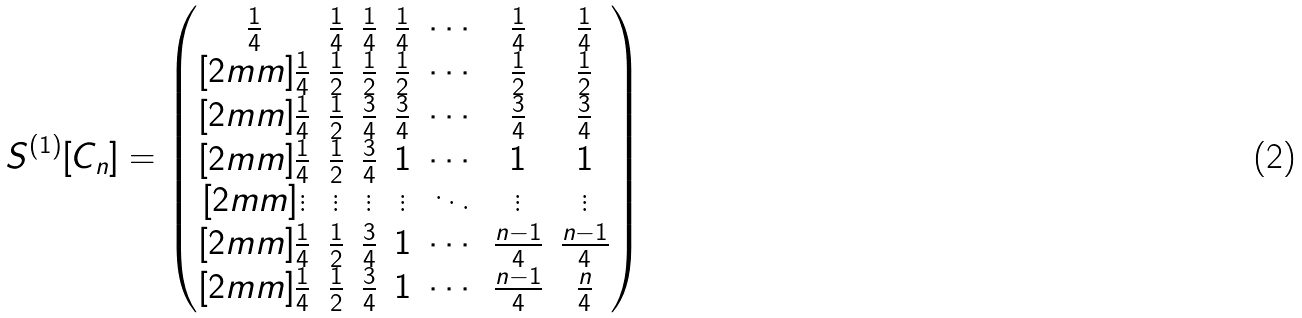<formula> <loc_0><loc_0><loc_500><loc_500>S ^ { ( 1 ) } [ C _ { n } ] & = \begin{pmatrix} \frac { 1 } { 4 } & \frac { 1 } { 4 } & \frac { 1 } { 4 } & \frac { 1 } { 4 } & \cdots & \frac { 1 } { 4 } & \frac { 1 } { 4 } \\ [ 2 m m ] \frac { 1 } { 4 } & \frac { 1 } { 2 } & \frac { 1 } { 2 } & \frac { 1 } { 2 } & \cdots & \frac { 1 } { 2 } & \frac { 1 } { 2 } \\ [ 2 m m ] \frac { 1 } { 4 } & \frac { 1 } { 2 } & \frac { 3 } { 4 } & \frac { 3 } { 4 } & \cdots & \frac { 3 } { 4 } & \frac { 3 } { 4 } \\ [ 2 m m ] \frac { 1 } { 4 } & \frac { 1 } { 2 } & \frac { 3 } { 4 } & 1 & \cdots & 1 & 1 \\ [ 2 m m ] \vdots & \vdots & \vdots & \vdots & \ddots & \vdots & \vdots \\ [ 2 m m ] \frac { 1 } { 4 } & \frac { 1 } { 2 } & \frac { 3 } { 4 } & 1 & \cdots & \frac { n - 1 } { 4 } & \frac { n - 1 } { 4 } \\ [ 2 m m ] \frac { 1 } { 4 } & \frac { 1 } { 2 } & \frac { 3 } { 4 } & 1 & \cdots & \frac { n - 1 } { 4 } & \frac { n } { 4 } \end{pmatrix}</formula> 